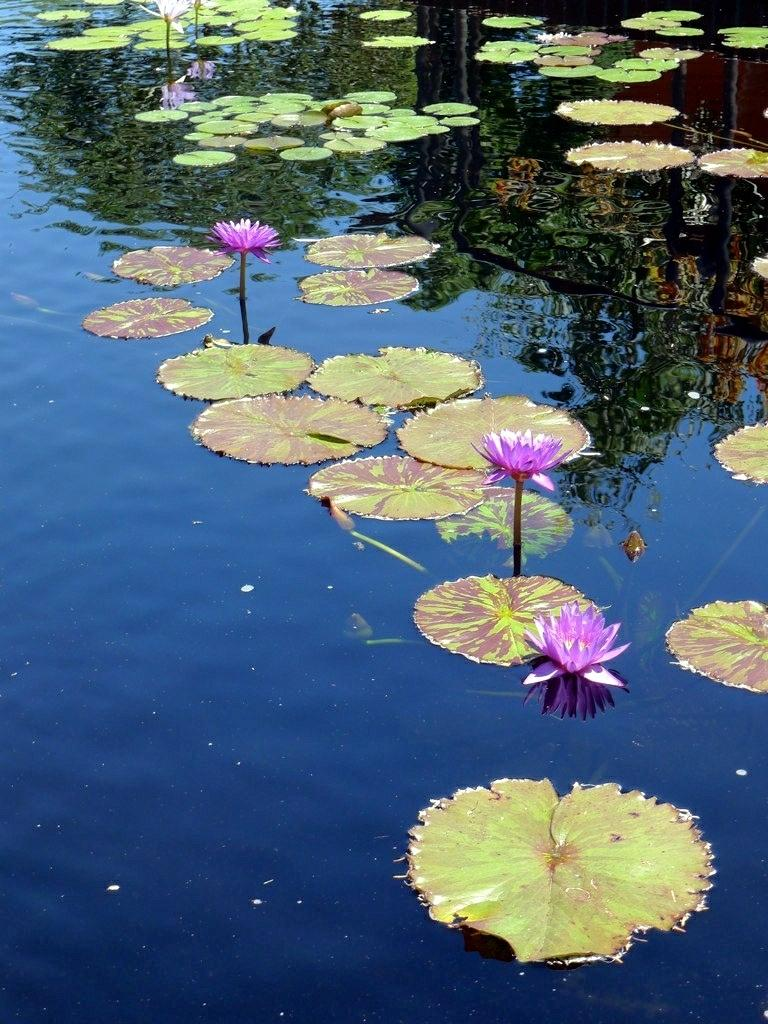What color are the flowers in the image? The flowers in the image are pink. What type of flowers are depicted in the image? The flowers in the image are lotus flowers. What else can be seen in the image besides the flowers? There are lotus leaves in the image. Where are the flowers and leaves located in the image? The lotus flowers and leaves are on the water. What is the price of the rock in the image? There is no rock present in the image. 